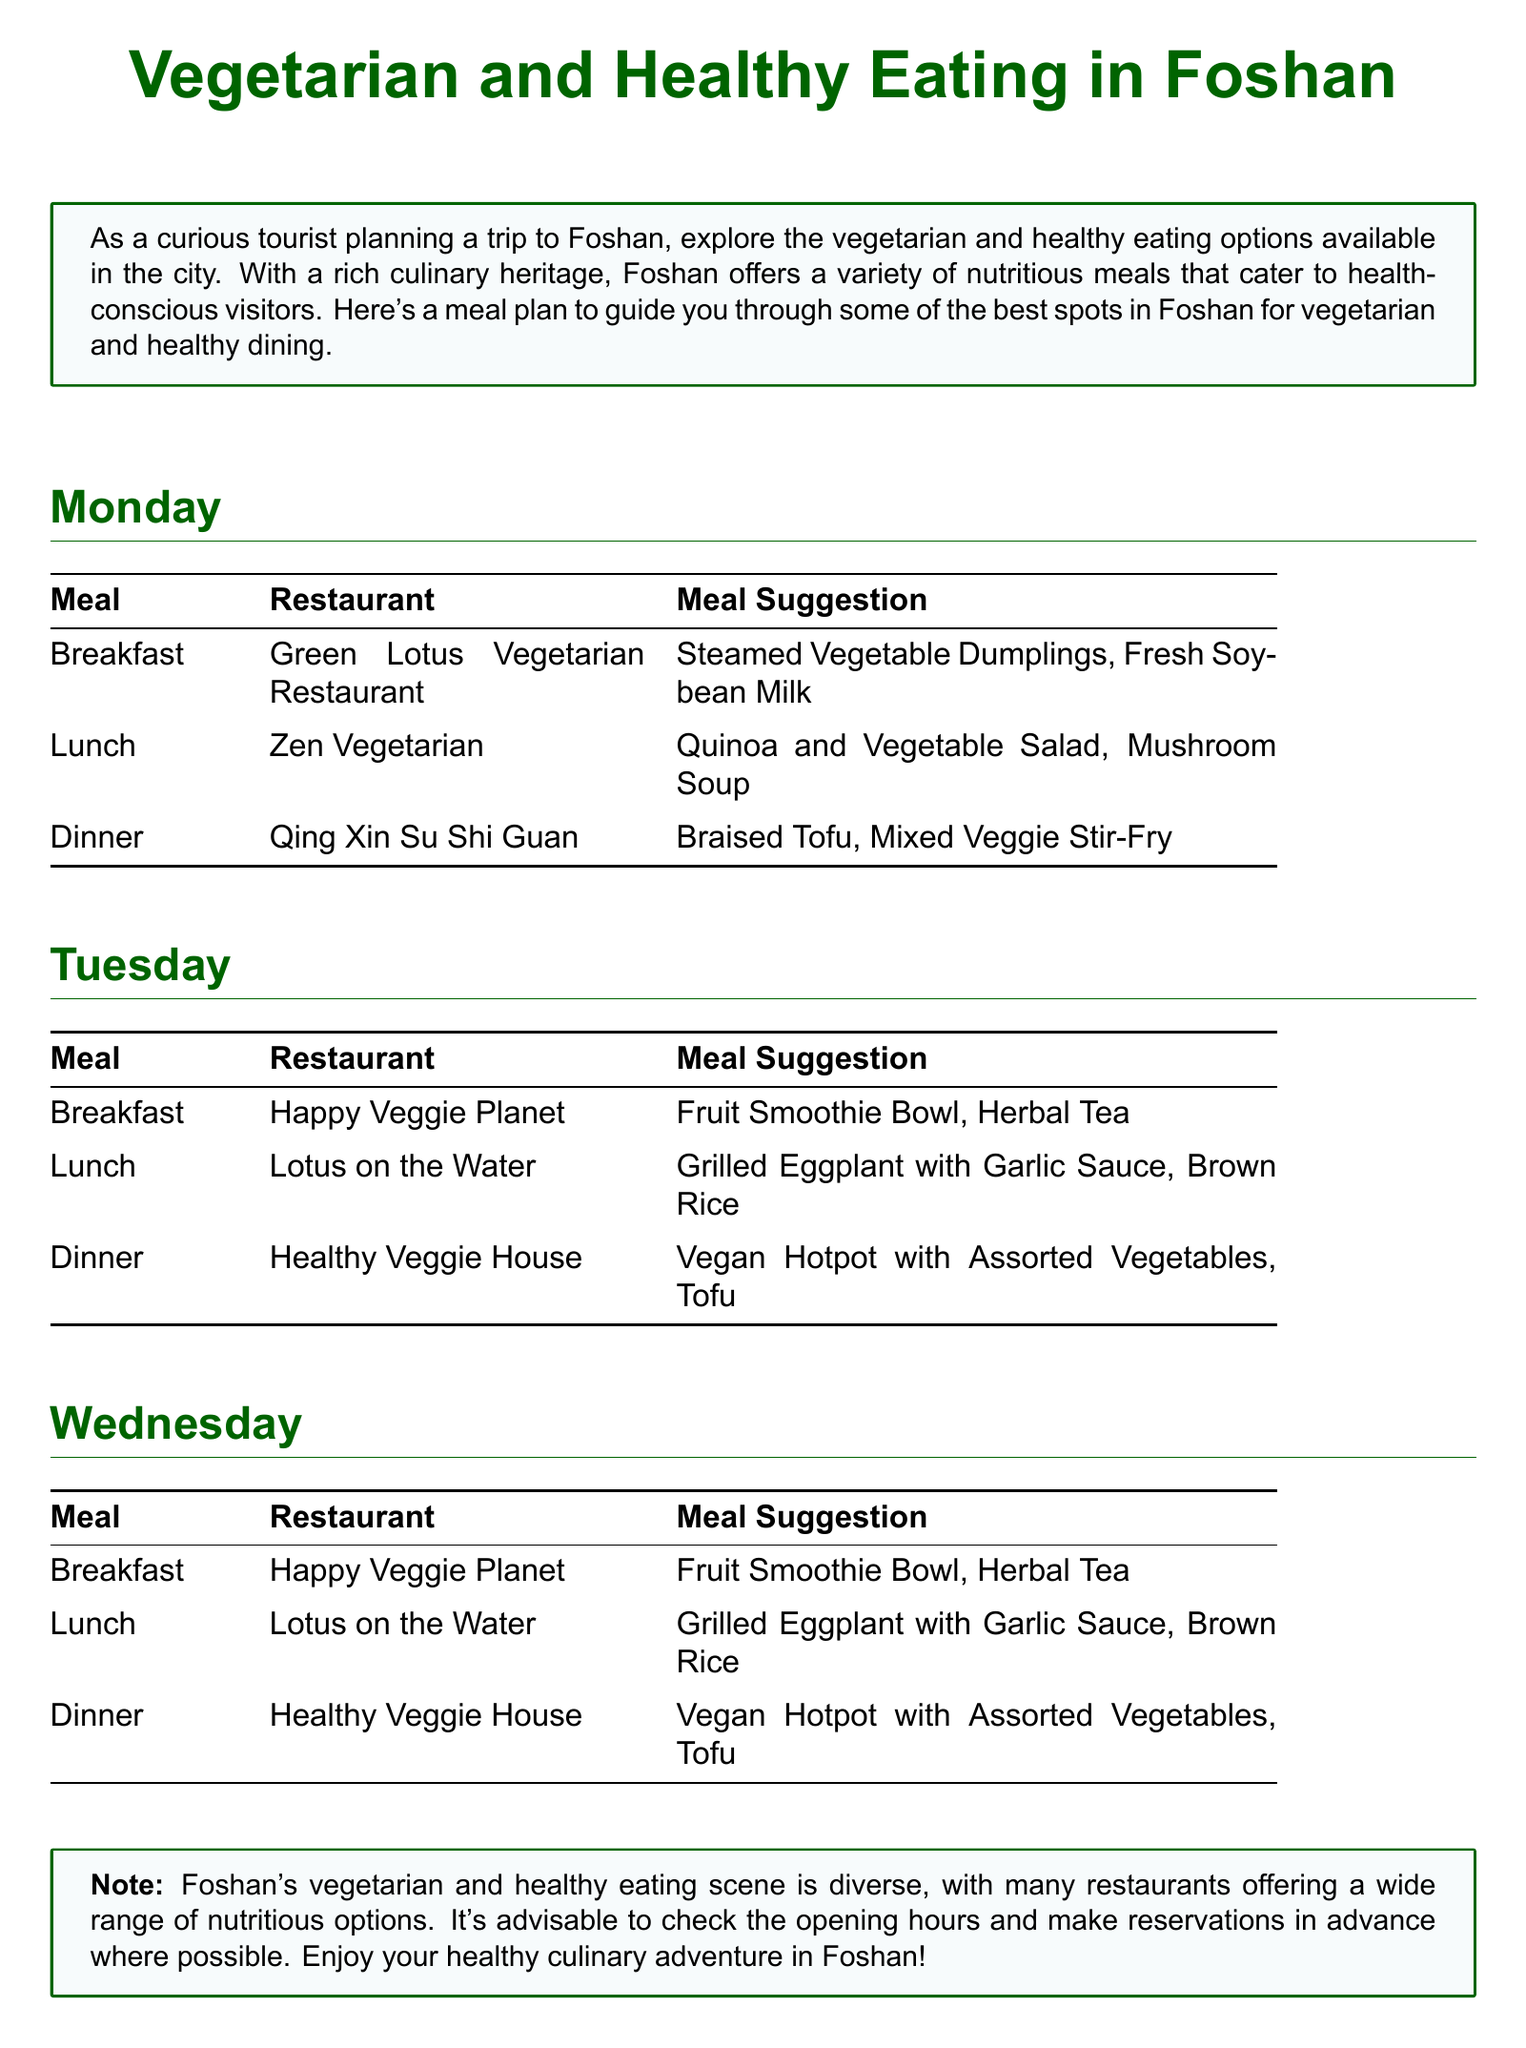What is the name of the restaurant for breakfast on Monday? The document lists "Green Lotus Vegetarian Restaurant" as the breakfast option for Monday.
Answer: Green Lotus Vegetarian Restaurant What meal is suggested for lunch on Tuesday? According to the meal plan, "Lotus on the Water" is suggested for lunch on Tuesday.
Answer: Lotus on the Water Which dish is recommended for dinner on Wednesday? The document specifies "Foshan Veggie" with "Veggie Sushi, Edamame" for dinner on Wednesday.
Answer: Veggie Sushi, Edamame How many restaurants are mentioned for lunch options in total? The document presents three lunch restaurant options for each of the three days: 3 days x 3 restaurants = 9 restaurants, which is noted throughout the document.
Answer: 9 Which drink is listed with the breakfast at Vitality Café? The breakfast suggestion for Vitality Café includes "Freshly Squeezed Orange Juice."
Answer: Freshly Squeezed Orange Juice What type of meal is noted for "Healthy Veggie House" for dinner? The document lists "Vegan Hotpot with Assorted Vegetables, Tofu" associated with "Healthy Veggie House" for dinner.
Answer: Vegan Hotpot with Assorted Vegetables, Tofu What is the note about reservations? The note emphasizes making reservations in advance where possible, which provides guidance to tourists.
Answer: Make reservations in advance 